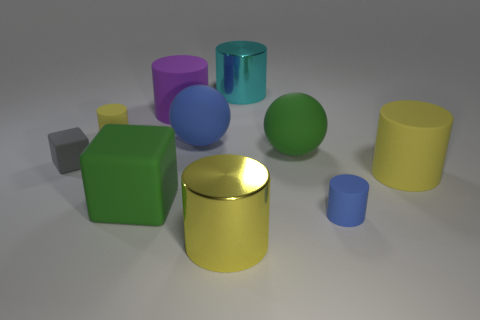How many yellow cylinders must be subtracted to get 1 yellow cylinders? 2 Subtract all cyan cubes. How many yellow cylinders are left? 3 Subtract all cyan cylinders. How many cylinders are left? 5 Subtract all small blue rubber cylinders. How many cylinders are left? 5 Subtract all purple cylinders. Subtract all red balls. How many cylinders are left? 5 Subtract all blocks. How many objects are left? 8 Add 6 tiny gray blocks. How many tiny gray blocks exist? 7 Subtract 0 yellow balls. How many objects are left? 10 Subtract all large cyan objects. Subtract all green rubber cubes. How many objects are left? 8 Add 5 blue rubber cylinders. How many blue rubber cylinders are left? 6 